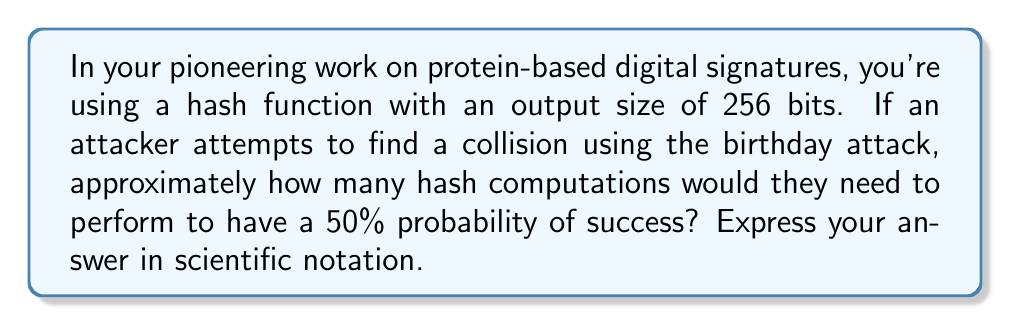Can you solve this math problem? To solve this problem, we'll use the birthday attack probability formula and the properties of hash functions:

1) The birthday attack exploits the birthday paradox to find collisions in hash functions.

2) For a hash function with an output size of $n$ bits, the number of possible hash values is $2^n$.

3) The probability of finding a collision after $k$ attempts is approximately:

   $P(collision) \approx 1 - e^{-k^2/(2 \cdot 2^n)}$

4) We want to find $k$ when $P(collision) = 0.5$ (50% probability of success).

5) Substituting these values:

   $0.5 \approx 1 - e^{-k^2/(2 \cdot 2^{256})}$

6) Solving for $k$:

   $0.5 = e^{-k^2/(2 \cdot 2^{256})}$
   $\ln(0.5) = -k^2/(2 \cdot 2^{256})$
   $k^2 = -2 \cdot 2^{256} \cdot \ln(0.5)$
   $k = \sqrt{-2 \cdot 2^{256} \cdot \ln(0.5)}$

7) Calculating this value:

   $k \approx 2^{128} \cdot \sqrt{-2\ln(0.5)} \approx 2^{128} \cdot 1.177 \approx 1.177 \cdot 2^{128}$

8) Converting to scientific notation:

   $k \approx 3.204 \times 10^{38}$

Therefore, an attacker would need to perform approximately $3.204 \times 10^{38}$ hash computations to have a 50% chance of finding a collision.
Answer: $3.204 \times 10^{38}$ 